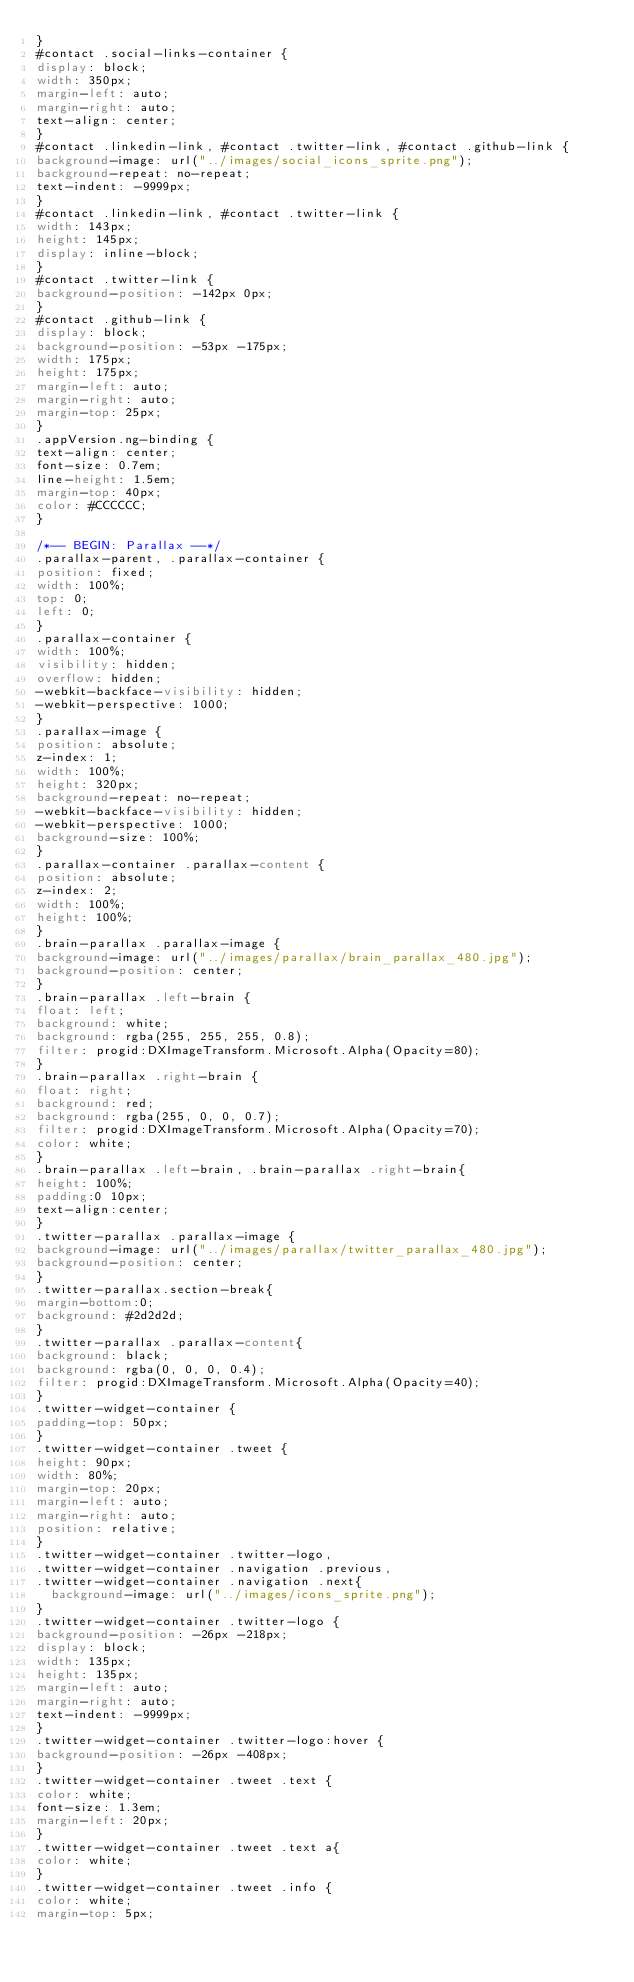Convert code to text. <code><loc_0><loc_0><loc_500><loc_500><_CSS_>}
#contact .social-links-container {
display: block;
width: 350px;
margin-left: auto;
margin-right: auto;
text-align: center;
}
#contact .linkedin-link, #contact .twitter-link, #contact .github-link {
background-image: url("../images/social_icons_sprite.png");
background-repeat: no-repeat;
text-indent: -9999px;
}
#contact .linkedin-link, #contact .twitter-link {
width: 143px;
height: 145px;
display: inline-block;
}
#contact .twitter-link {
background-position: -142px 0px;
}
#contact .github-link {
display: block;
background-position: -53px -175px;
width: 175px;
height: 175px;
margin-left: auto;
margin-right: auto;
margin-top: 25px;
}
.appVersion.ng-binding {
text-align: center;
font-size: 0.7em;
line-height: 1.5em;
margin-top: 40px;
color: #CCCCCC;
}

/*-- BEGIN: Parallax --*/
.parallax-parent, .parallax-container {
position: fixed;
width: 100%;
top: 0;
left: 0;
}
.parallax-container {
width: 100%;
visibility: hidden;
overflow: hidden;
-webkit-backface-visibility: hidden;
-webkit-perspective: 1000;
}
.parallax-image {
position: absolute;
z-index: 1;
width: 100%;
height: 320px;
background-repeat: no-repeat;
-webkit-backface-visibility: hidden;
-webkit-perspective: 1000;
background-size: 100%;
}
.parallax-container .parallax-content {
position: absolute;
z-index: 2;
width: 100%;
height: 100%;
}
.brain-parallax .parallax-image {
background-image: url("../images/parallax/brain_parallax_480.jpg");
background-position: center;
}
.brain-parallax .left-brain {
float: left;
background: white;
background: rgba(255, 255, 255, 0.8);
filter: progid:DXImageTransform.Microsoft.Alpha(Opacity=80);
}
.brain-parallax .right-brain {
float: right;
background: red;
background: rgba(255, 0, 0, 0.7);
filter: progid:DXImageTransform.Microsoft.Alpha(Opacity=70);
color: white;
}
.brain-parallax .left-brain, .brain-parallax .right-brain{
height: 100%;
padding:0 10px;
text-align:center;
}
.twitter-parallax .parallax-image {
background-image: url("../images/parallax/twitter_parallax_480.jpg");
background-position: center;
}
.twitter-parallax.section-break{
margin-bottom:0;
background: #2d2d2d;
}
.twitter-parallax .parallax-content{
background: black;
background: rgba(0, 0, 0, 0.4);
filter: progid:DXImageTransform.Microsoft.Alpha(Opacity=40);
}
.twitter-widget-container {
padding-top: 50px;
}
.twitter-widget-container .tweet {
height: 90px;
width: 80%;
margin-top: 20px;
margin-left: auto;
margin-right: auto;
position: relative;
}
.twitter-widget-container .twitter-logo,
.twitter-widget-container .navigation .previous,
.twitter-widget-container .navigation .next{
  background-image: url("../images/icons_sprite.png");
}
.twitter-widget-container .twitter-logo {
background-position: -26px -218px;
display: block;
width: 135px;
height: 135px;
margin-left: auto;
margin-right: auto;
text-indent: -9999px;
}
.twitter-widget-container .twitter-logo:hover {
background-position: -26px -408px;
}
.twitter-widget-container .tweet .text {
color: white;
font-size: 1.3em;
margin-left: 20px;
}
.twitter-widget-container .tweet .text a{
color: white;
}
.twitter-widget-container .tweet .info {
color: white;
margin-top: 5px;</code> 